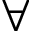<formula> <loc_0><loc_0><loc_500><loc_500>\forall</formula> 